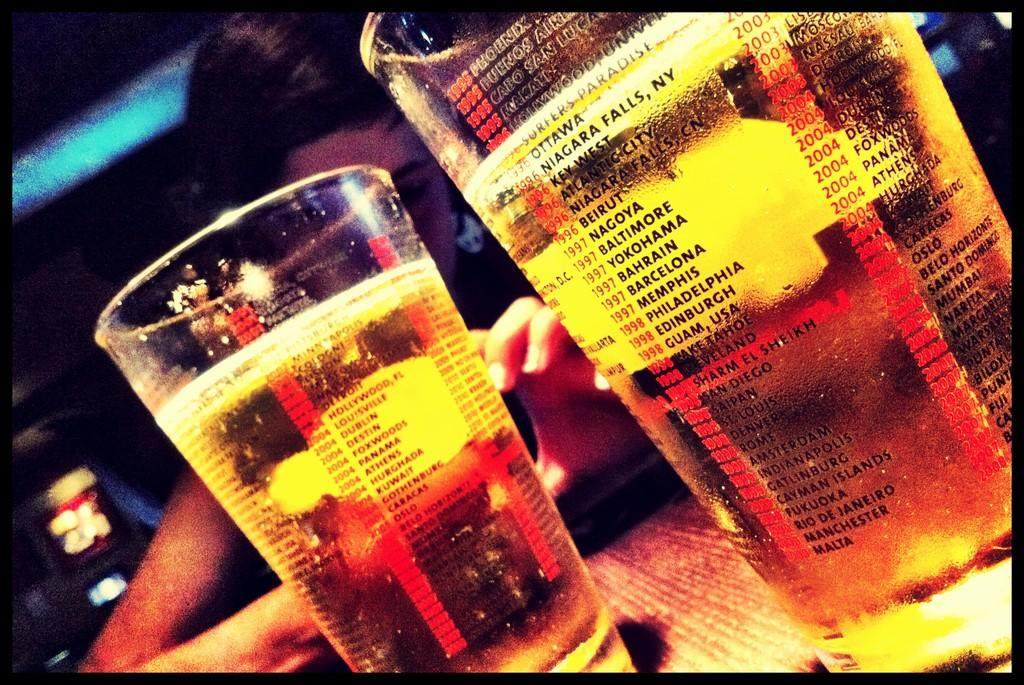<image>
Summarize the visual content of the image. Two glasses that list city names, including Phoenix and Buenos Aires, are on a table. 